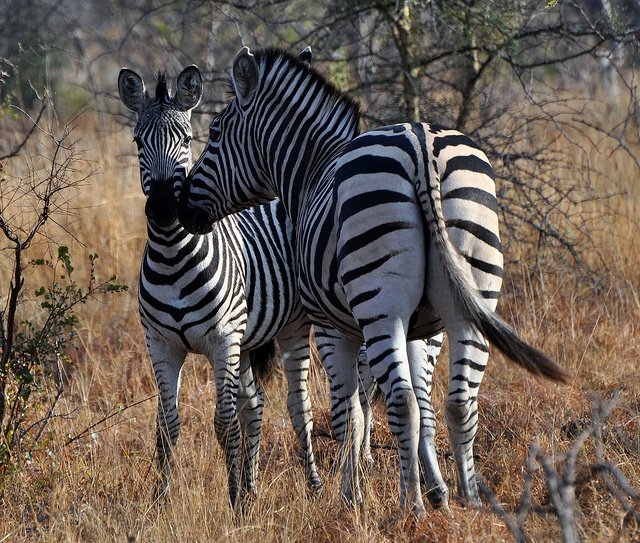Describe the objects in this image and their specific colors. I can see zebra in purple, black, gray, and lightgray tones and zebra in purple, black, gray, white, and darkgray tones in this image. 